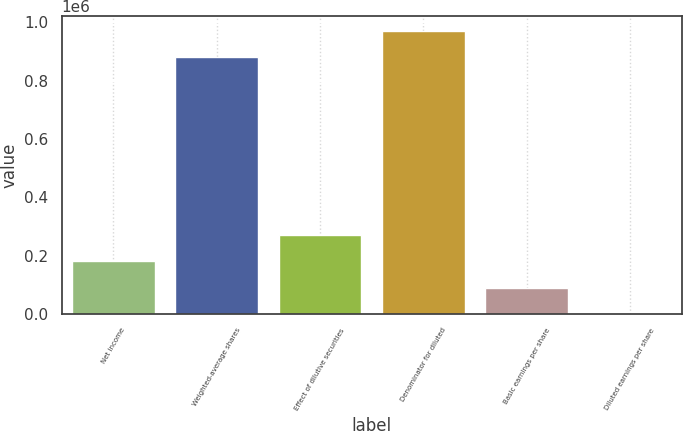Convert chart. <chart><loc_0><loc_0><loc_500><loc_500><bar_chart><fcel>Net income<fcel>Weighted-average shares<fcel>Effect of dilutive securities<fcel>Denominator for diluted<fcel>Basic earnings per share<fcel>Diluted earnings per share<nl><fcel>180432<fcel>881592<fcel>270645<fcel>971805<fcel>90218.7<fcel>5.36<nl></chart> 